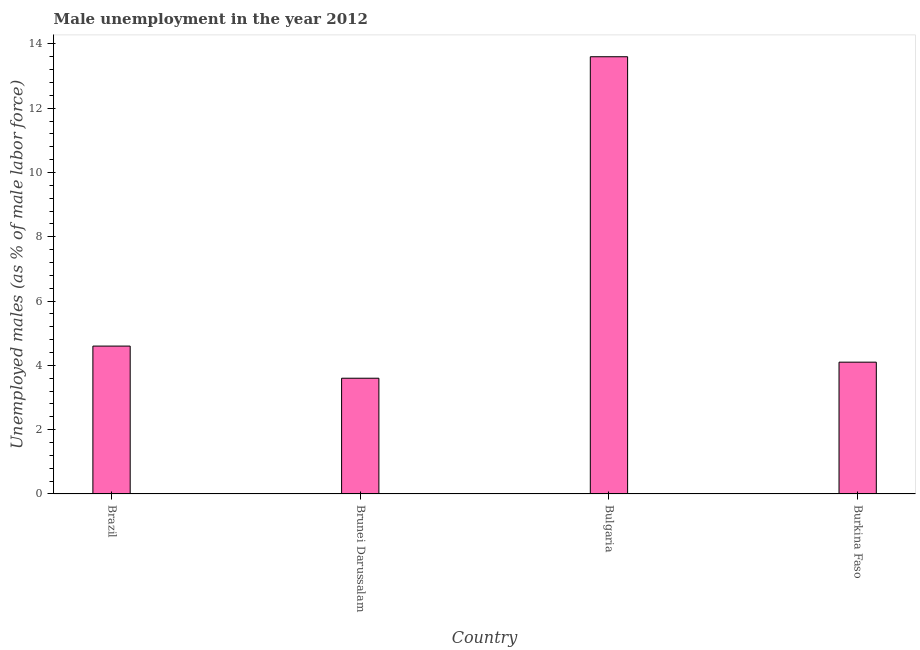Does the graph contain any zero values?
Give a very brief answer. No. What is the title of the graph?
Provide a short and direct response. Male unemployment in the year 2012. What is the label or title of the X-axis?
Keep it short and to the point. Country. What is the label or title of the Y-axis?
Give a very brief answer. Unemployed males (as % of male labor force). What is the unemployed males population in Brazil?
Ensure brevity in your answer.  4.6. Across all countries, what is the maximum unemployed males population?
Provide a succinct answer. 13.6. Across all countries, what is the minimum unemployed males population?
Offer a very short reply. 3.6. In which country was the unemployed males population maximum?
Make the answer very short. Bulgaria. In which country was the unemployed males population minimum?
Ensure brevity in your answer.  Brunei Darussalam. What is the sum of the unemployed males population?
Give a very brief answer. 25.9. What is the average unemployed males population per country?
Your answer should be compact. 6.47. What is the median unemployed males population?
Keep it short and to the point. 4.35. In how many countries, is the unemployed males population greater than 5.6 %?
Your answer should be compact. 1. What is the ratio of the unemployed males population in Brazil to that in Bulgaria?
Make the answer very short. 0.34. Is the unemployed males population in Brazil less than that in Bulgaria?
Give a very brief answer. Yes. Is the difference between the unemployed males population in Brazil and Bulgaria greater than the difference between any two countries?
Your answer should be very brief. No. What is the difference between the highest and the second highest unemployed males population?
Provide a short and direct response. 9. In how many countries, is the unemployed males population greater than the average unemployed males population taken over all countries?
Your response must be concise. 1. Are the values on the major ticks of Y-axis written in scientific E-notation?
Keep it short and to the point. No. What is the Unemployed males (as % of male labor force) of Brazil?
Ensure brevity in your answer.  4.6. What is the Unemployed males (as % of male labor force) of Brunei Darussalam?
Your answer should be very brief. 3.6. What is the Unemployed males (as % of male labor force) of Bulgaria?
Give a very brief answer. 13.6. What is the Unemployed males (as % of male labor force) in Burkina Faso?
Offer a very short reply. 4.1. What is the difference between the Unemployed males (as % of male labor force) in Brazil and Brunei Darussalam?
Make the answer very short. 1. What is the difference between the Unemployed males (as % of male labor force) in Brazil and Bulgaria?
Offer a very short reply. -9. What is the difference between the Unemployed males (as % of male labor force) in Brazil and Burkina Faso?
Ensure brevity in your answer.  0.5. What is the difference between the Unemployed males (as % of male labor force) in Brunei Darussalam and Burkina Faso?
Your response must be concise. -0.5. What is the ratio of the Unemployed males (as % of male labor force) in Brazil to that in Brunei Darussalam?
Offer a very short reply. 1.28. What is the ratio of the Unemployed males (as % of male labor force) in Brazil to that in Bulgaria?
Keep it short and to the point. 0.34. What is the ratio of the Unemployed males (as % of male labor force) in Brazil to that in Burkina Faso?
Provide a short and direct response. 1.12. What is the ratio of the Unemployed males (as % of male labor force) in Brunei Darussalam to that in Bulgaria?
Give a very brief answer. 0.27. What is the ratio of the Unemployed males (as % of male labor force) in Brunei Darussalam to that in Burkina Faso?
Keep it short and to the point. 0.88. What is the ratio of the Unemployed males (as % of male labor force) in Bulgaria to that in Burkina Faso?
Your answer should be very brief. 3.32. 